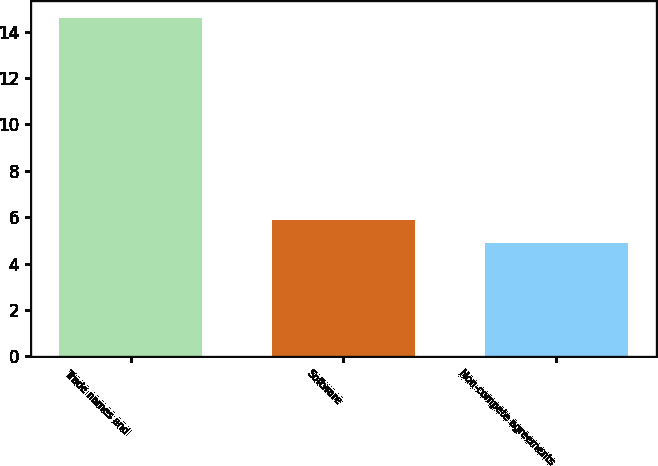<chart> <loc_0><loc_0><loc_500><loc_500><bar_chart><fcel>Trade names and<fcel>Software<fcel>Non-compete agreements<nl><fcel>14.6<fcel>5.87<fcel>4.9<nl></chart> 